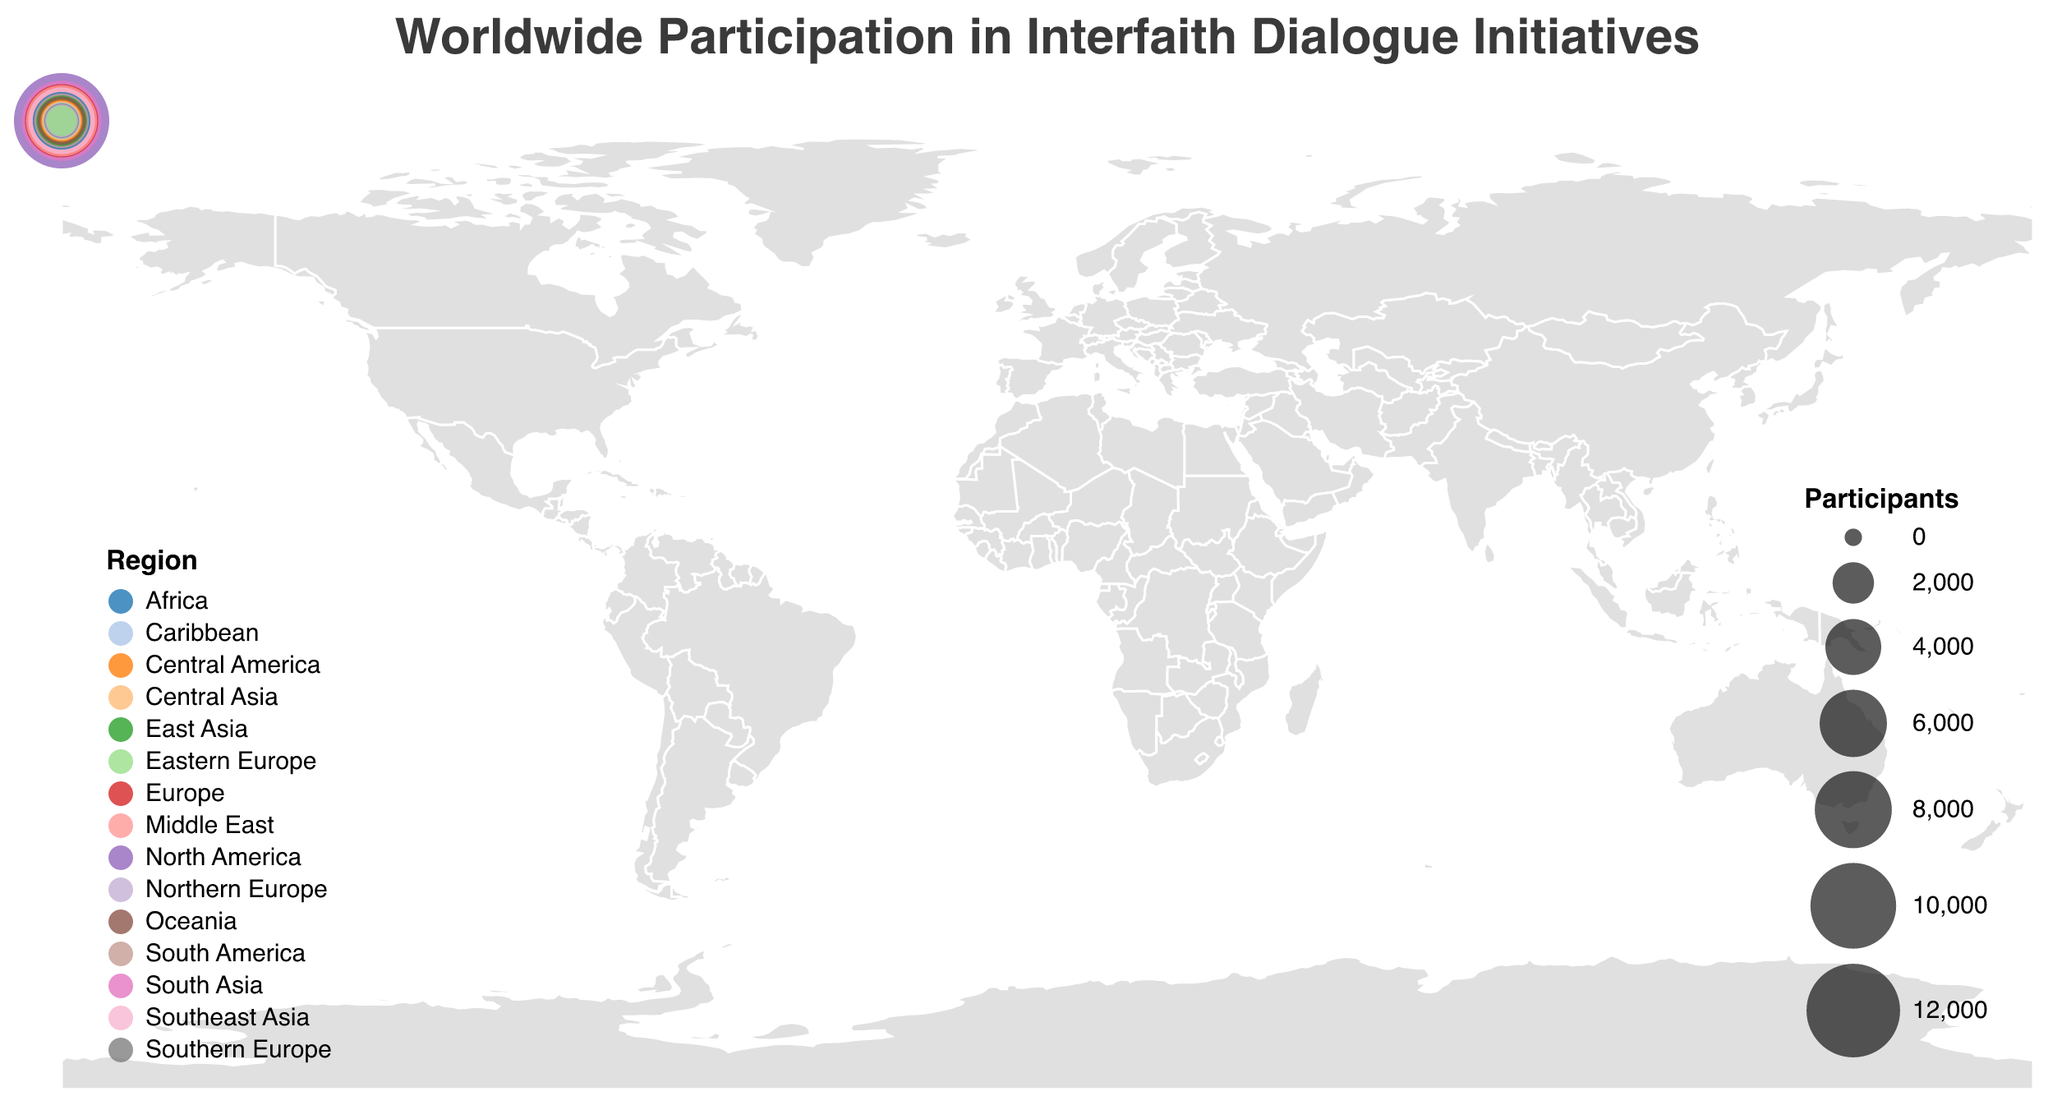How many regions are represented in the figure? By counting the unique regions listed in the tooltip, we identify 15 distinct regions.
Answer: 15 Which country has the highest participation in interfaith dialogues? From the tooltip data, the United States has the highest number of participants with 12,500.
Answer: United States What is the total number of participants from South Asia? Only Pakistan is listed from South Asia with 8,700 participants.
Answer: 8700 Which region has more participants: the Middle East or Southeast Asia? Comparing the figures, the Middle East (UAE: 6,800) has more participants than Southeast Asia (Indonesia: 5,900).
Answer: Middle East What is the average number of participants across all the listed regions? Sum all participant numbers and divide by the number of regions: (12,500 + 8,700 + 7,200 + 6,800 + 5,900 + 4,300 + 3,800 + 3,200 + 2,900 + 2,100 + 1,800 + 1,500 + 1,300 + 1,100 + 900) / 15 ≈ 4,206.
Answer: 4206 Which countries have participants fewer than 2,000? Reviewing the participant numbers, these countries have fewer than 2,000 participants: Kazakhstan (1,800), Trinidad and Tobago (1,500), Spain (1,300), Sweden (1,100), and Poland (900).
Answer: Kazakhstan, Trinidad and Tobago, Spain, Sweden, Poland Which region has the lowest number of participants? Eastern Europe (Poland) has the lowest number with 900 participants.
Answer: Eastern Europe What is the combined number of participants from North and Central America? Adding the participants from the United States (12,500) and Mexico (2,100) gives 14,600.
Answer: 14600 